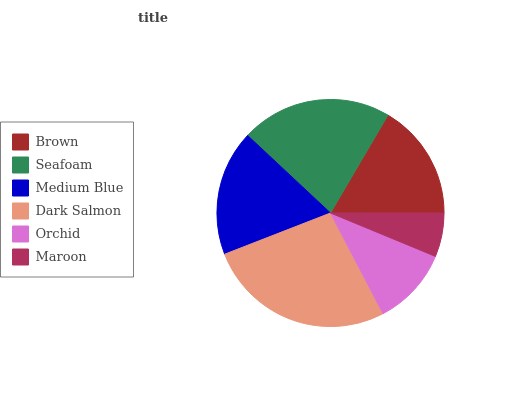Is Maroon the minimum?
Answer yes or no. Yes. Is Dark Salmon the maximum?
Answer yes or no. Yes. Is Seafoam the minimum?
Answer yes or no. No. Is Seafoam the maximum?
Answer yes or no. No. Is Seafoam greater than Brown?
Answer yes or no. Yes. Is Brown less than Seafoam?
Answer yes or no. Yes. Is Brown greater than Seafoam?
Answer yes or no. No. Is Seafoam less than Brown?
Answer yes or no. No. Is Medium Blue the high median?
Answer yes or no. Yes. Is Brown the low median?
Answer yes or no. Yes. Is Dark Salmon the high median?
Answer yes or no. No. Is Dark Salmon the low median?
Answer yes or no. No. 